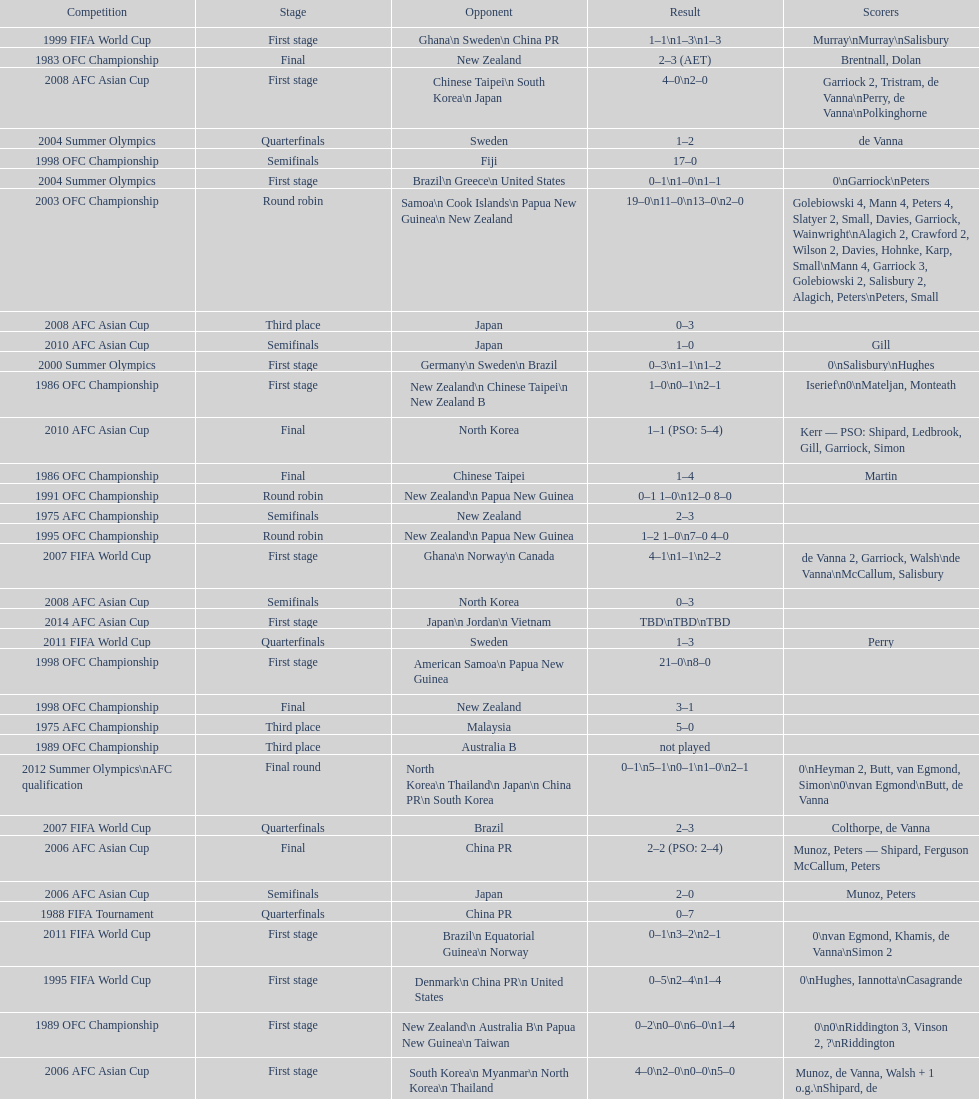Who was this team's next opponent after facing new zealand in the first stage of the 1986 ofc championship? Chinese Taipei. 